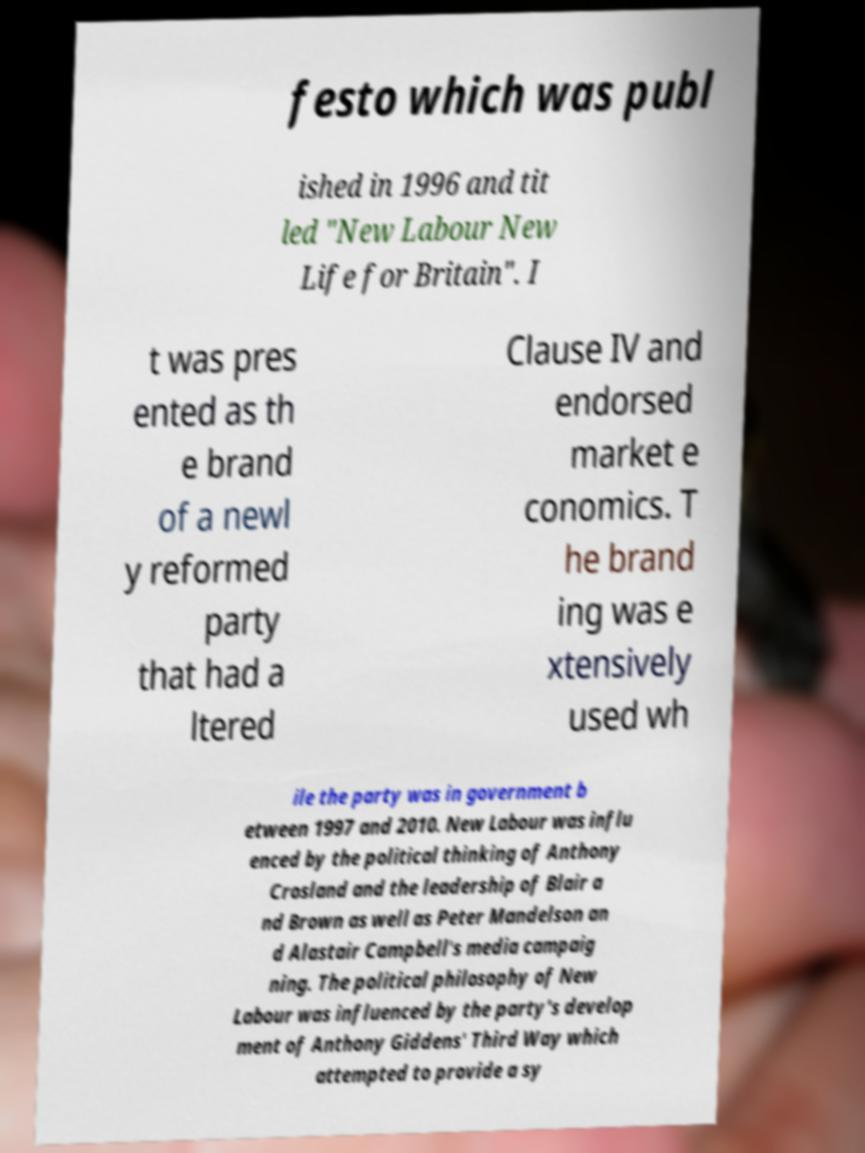Can you accurately transcribe the text from the provided image for me? festo which was publ ished in 1996 and tit led "New Labour New Life for Britain". I t was pres ented as th e brand of a newl y reformed party that had a ltered Clause IV and endorsed market e conomics. T he brand ing was e xtensively used wh ile the party was in government b etween 1997 and 2010. New Labour was influ enced by the political thinking of Anthony Crosland and the leadership of Blair a nd Brown as well as Peter Mandelson an d Alastair Campbell's media campaig ning. The political philosophy of New Labour was influenced by the party's develop ment of Anthony Giddens' Third Way which attempted to provide a sy 